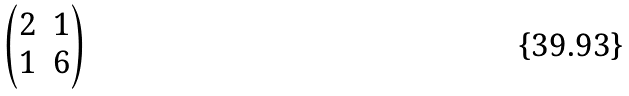<formula> <loc_0><loc_0><loc_500><loc_500>\begin{pmatrix} 2 & 1 \\ 1 & 6 \end{pmatrix}</formula> 